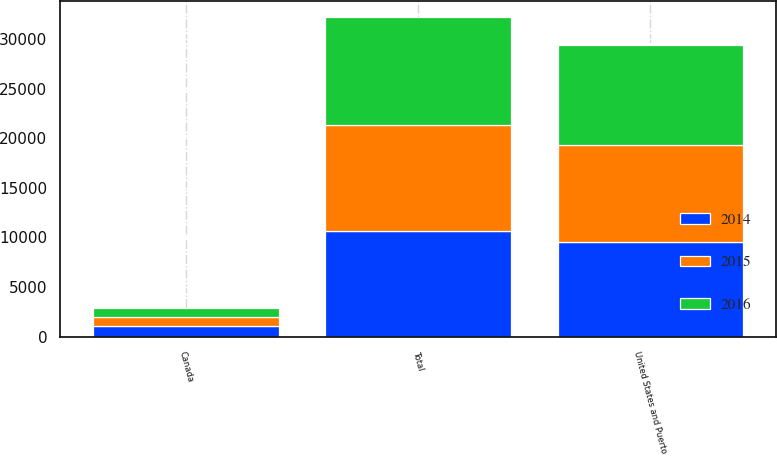Convert chart to OTSL. <chart><loc_0><loc_0><loc_500><loc_500><stacked_bar_chart><ecel><fcel>United States and Puerto<fcel>Canada<fcel>Total<nl><fcel>2016<fcel>10040<fcel>910<fcel>10950<nl><fcel>2015<fcel>9778<fcel>887<fcel>10665<nl><fcel>2014<fcel>9586<fcel>1071<fcel>10657<nl></chart> 